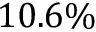Convert formula to latex. <formula><loc_0><loc_0><loc_500><loc_500>1 0 . 6 \%</formula> 